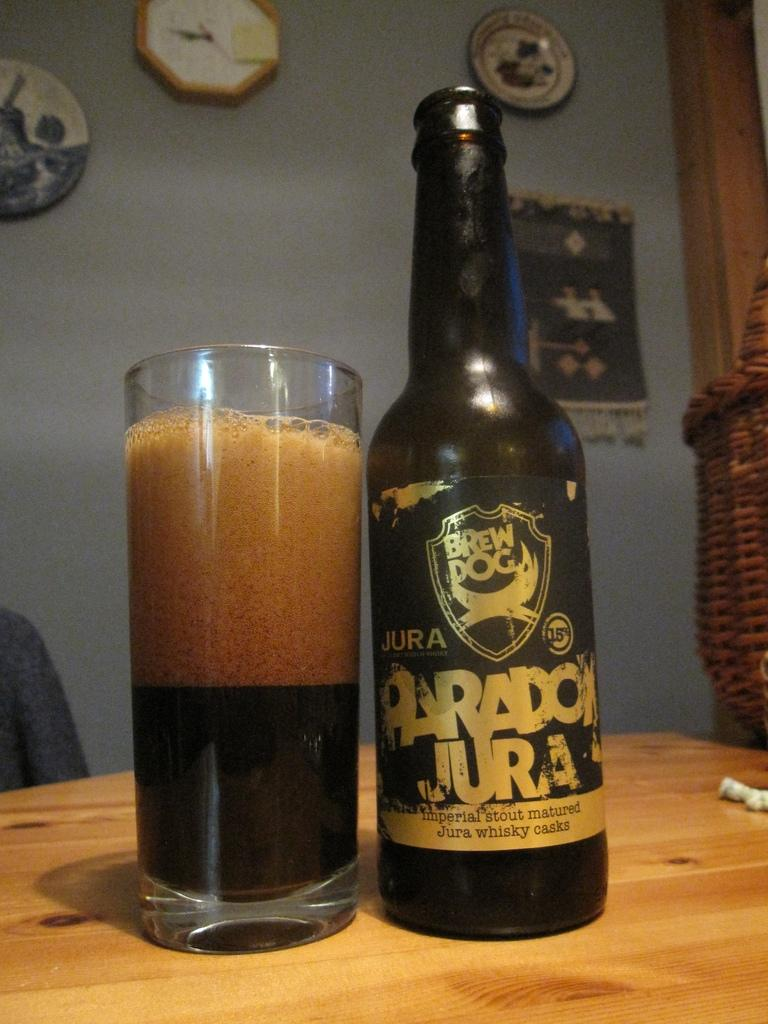What is present on the table in the image? There is a bottle and a glass on the table in the image. What can be seen hanging on the wall in the image? There is a cloth on the wall in the image. What time-telling device is visible in the image? There is a wall clock in the image. Are there any personal items or souvenirs in the image? Yes, there are mementos in the image. What type of crime is being committed in the image? There is no crime being committed in the image; it features a bottle, a glass, a wall clock, mementos, and a cloth on the wall. How does the lock on the door function in the image? There is no door or lock present in the image. 